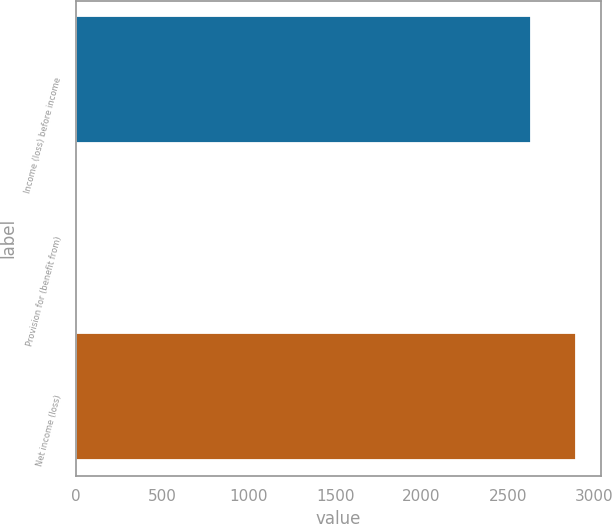Convert chart to OTSL. <chart><loc_0><loc_0><loc_500><loc_500><bar_chart><fcel>Income (loss) before income<fcel>Provision for (benefit from)<fcel>Net income (loss)<nl><fcel>2631.8<fcel>1.8<fcel>2894.98<nl></chart> 